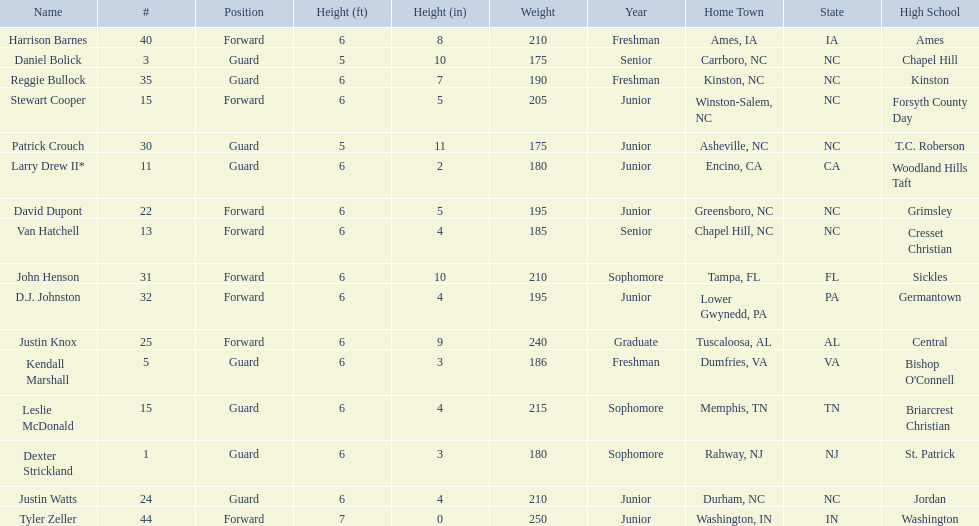What was the number of freshmen on the team? 3. 